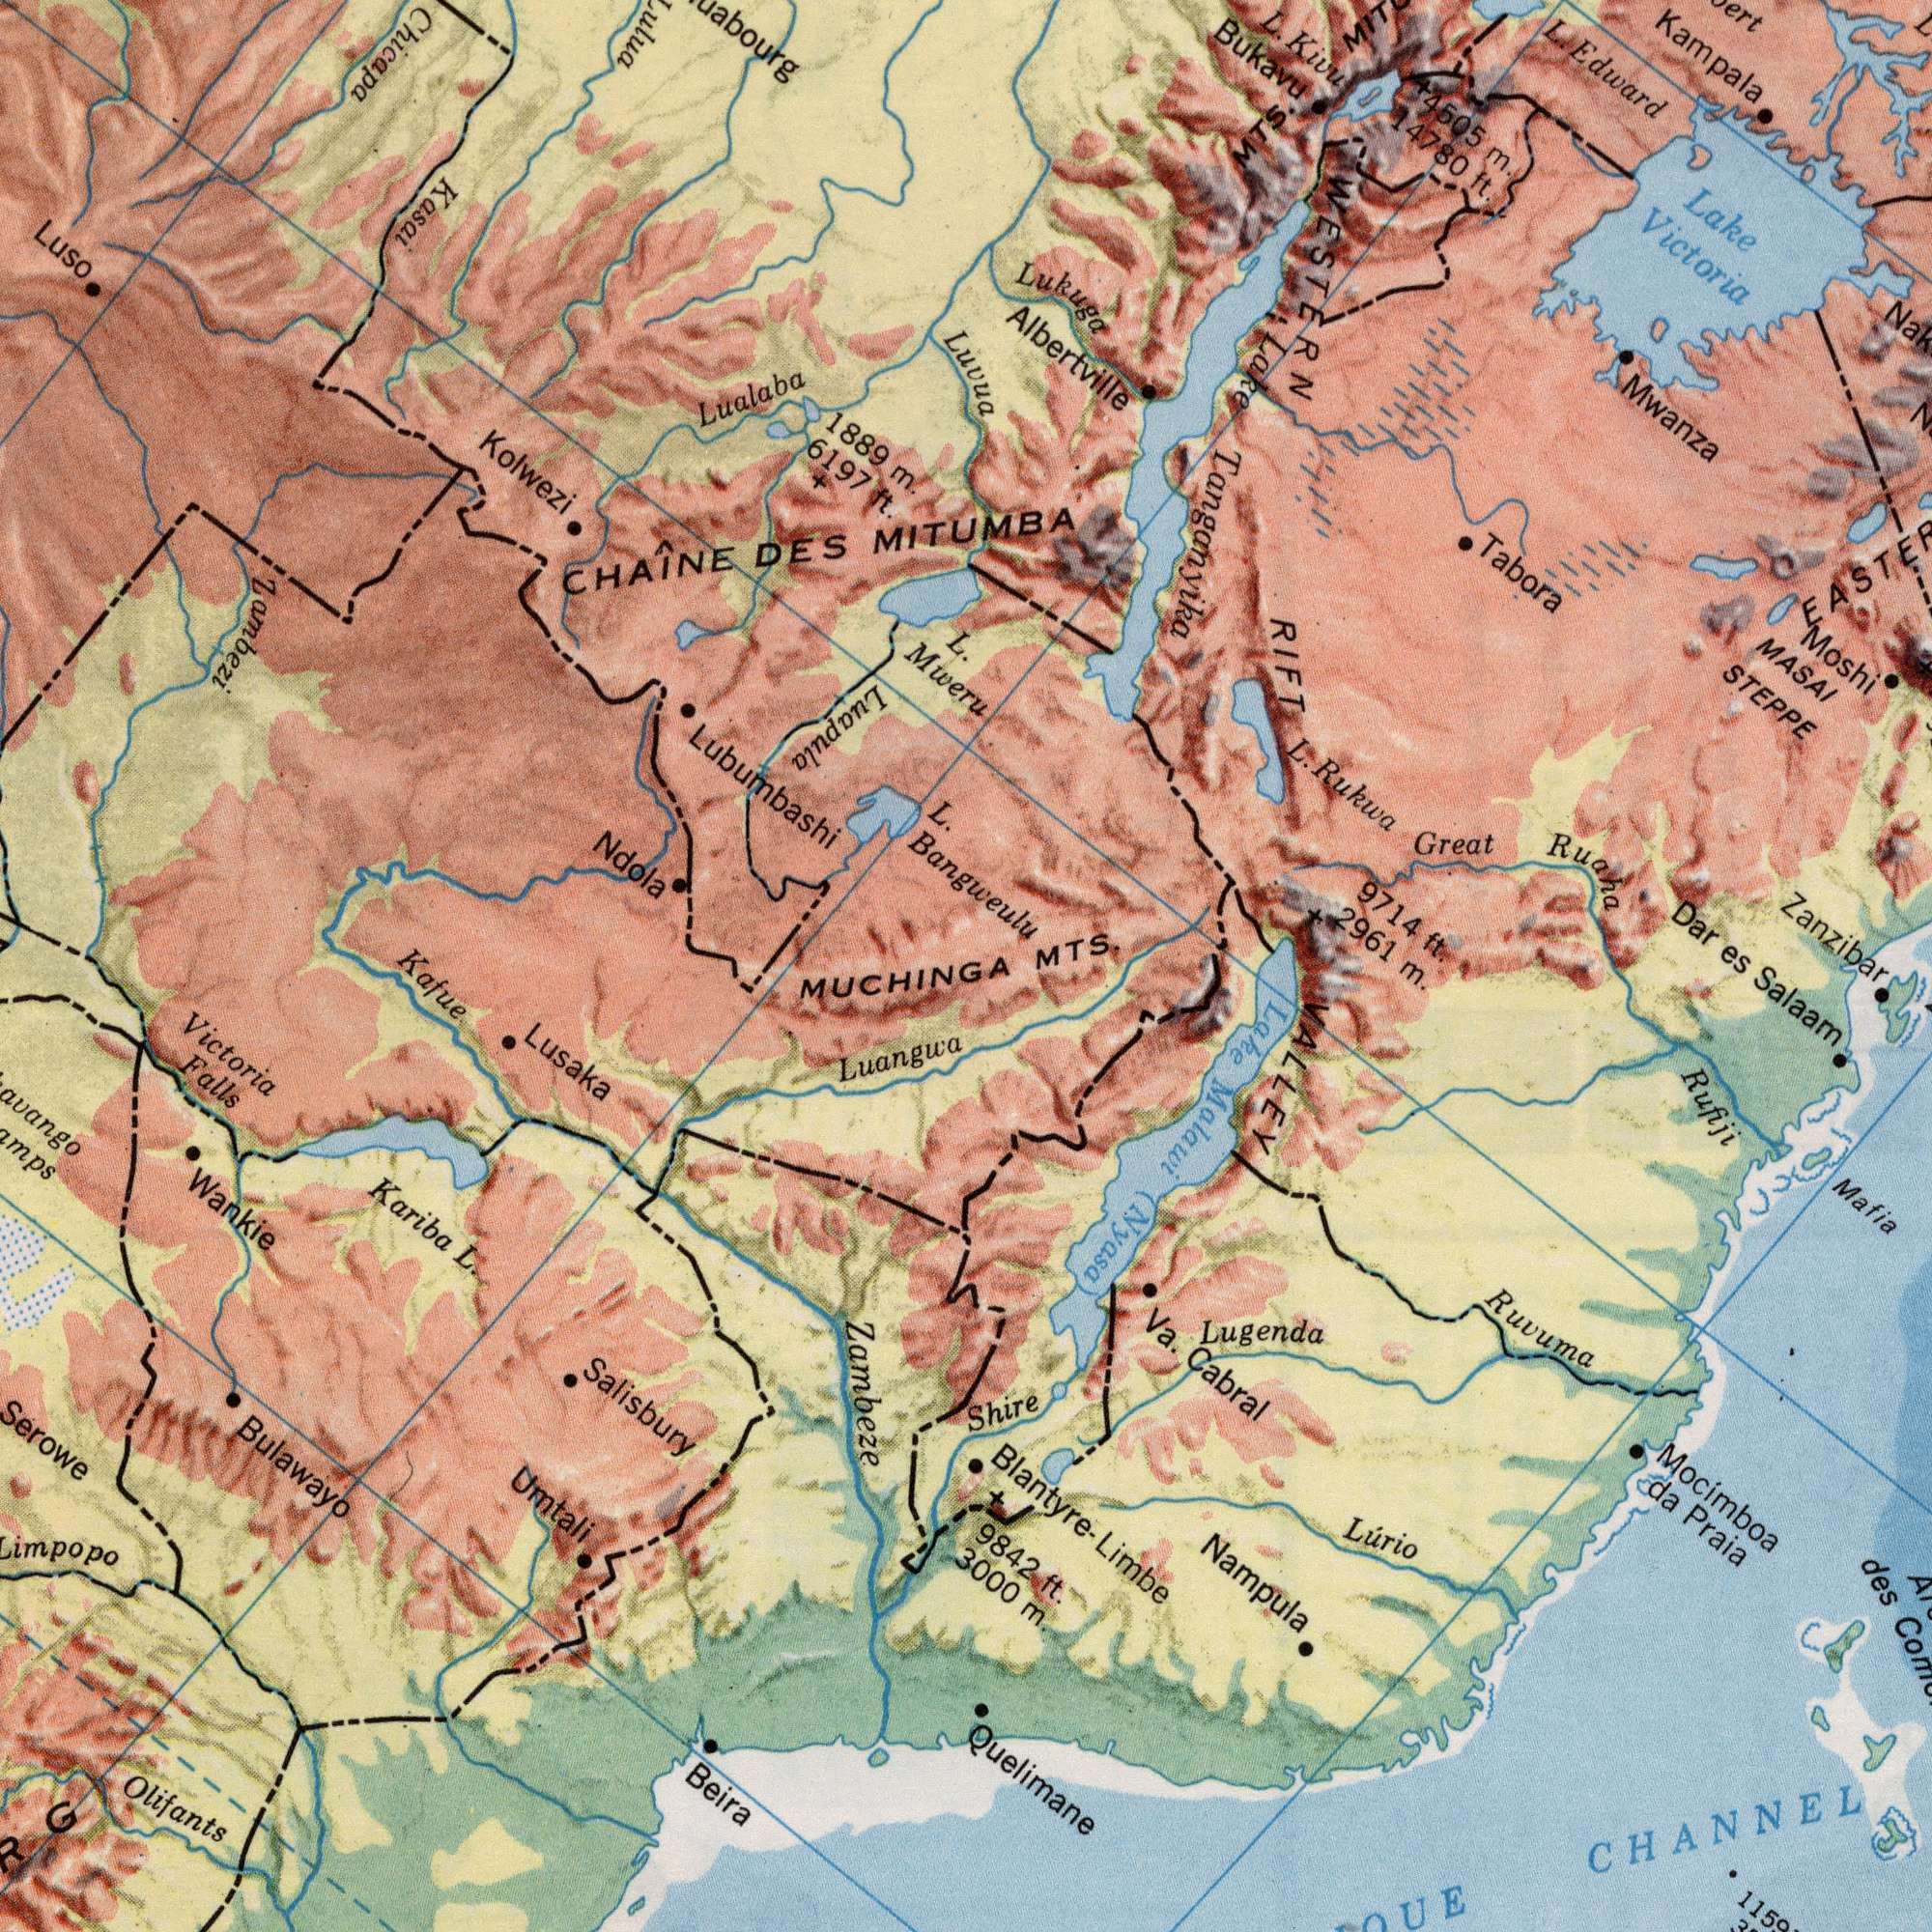What text appears in the bottom-left area of the image? MUCHINGA Lusaka Victoria Falls Bulawayo Kariba L. Luangwa Salisbury Olifants Beira Umtali Zambeze Wankie Serowe Kafue What text is visible in the upper-left corner? Lubumbashi CHAÎNE DES Lualaba Ndola Luso Luapula 1889 m. Kolwezi 6197 ft. Chicapa Kasai Mweru L. Zambezi What text can you see in the bottom-right section? MTS. es Salaam m. ft. Blantyre- Limbe Ruvuma Nampula Lugenda Mocimboa da Praia Mafia Shire Va. Cabral Lurio 9842 it. Lake Malawi (Nyasa) des Rufiji Quelimane VALLEY CHANNEL 3000 m. What text can you see in the top-right section? MITUMBA Lake Victoria Lukuga Albertville Zanzibar Kampala Moshi MASAI STEPPE Bukavu L. Rukwa Tabora L. Kivu L. Edward Great Ruaha Dar 2961 9714 WESTERN RIFT MTS. Mwanza Luvua L. Bangweulu Lake Tanganyika 4505 m. 14780 ft. 